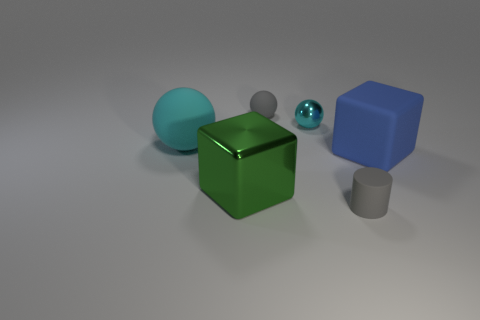Subtract all tiny balls. How many balls are left? 1 Add 1 tiny matte spheres. How many objects exist? 7 Subtract all green blocks. How many blocks are left? 1 Subtract all brown blocks. How many cyan balls are left? 2 Subtract all cylinders. How many objects are left? 5 Subtract 2 balls. How many balls are left? 1 Subtract all brown blocks. Subtract all brown cylinders. How many blocks are left? 2 Subtract all cyan matte things. Subtract all gray rubber cylinders. How many objects are left? 4 Add 3 large cyan matte balls. How many large cyan matte balls are left? 4 Add 4 gray balls. How many gray balls exist? 5 